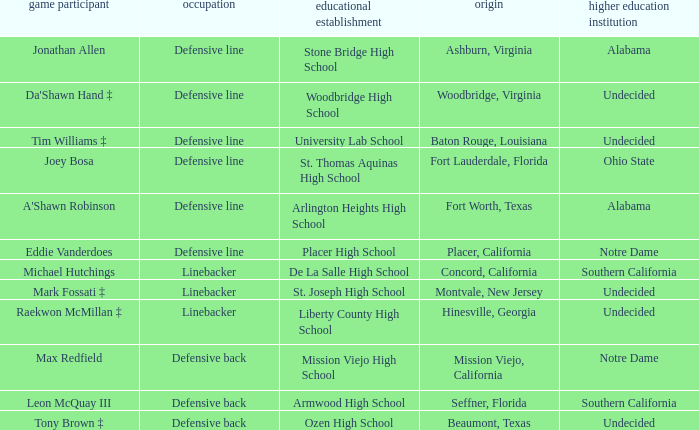What college did the player from Liberty County High School attend? Undecided. 